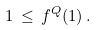Convert formula to latex. <formula><loc_0><loc_0><loc_500><loc_500>\, \ 1 \, \leq \, f ^ { Q } ( 1 ) \, .</formula> 